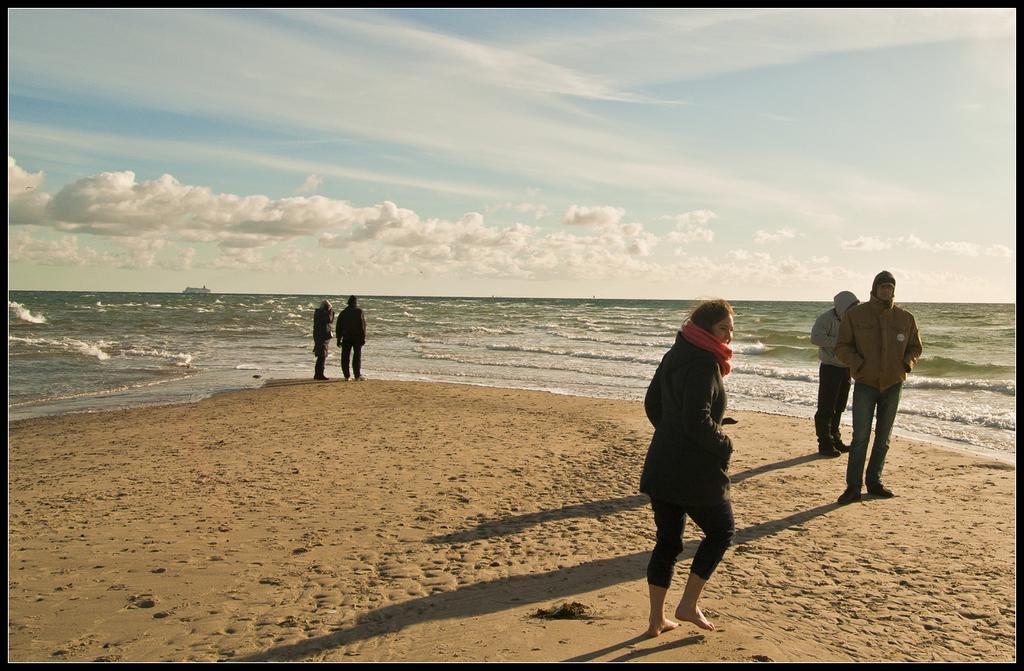Can you describe this image briefly? There is a sea and in front of the sea some people are standing on the sand and enjoying the view. 